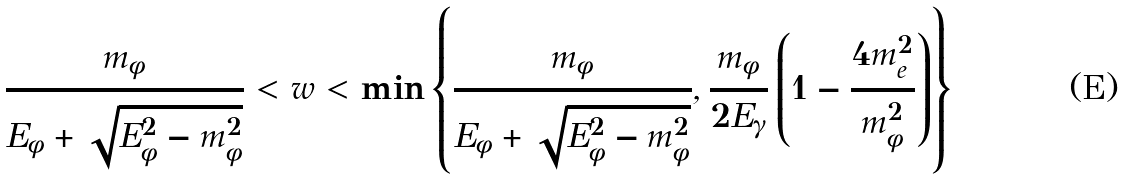<formula> <loc_0><loc_0><loc_500><loc_500>\frac { m _ { \phi } } { E _ { \phi } + \sqrt { E _ { \phi } ^ { 2 } - m _ { \phi } ^ { 2 } } } < w < \min \left \{ \frac { m _ { \phi } } { E _ { \phi } + \sqrt { E _ { \phi } ^ { 2 } - m _ { \phi } ^ { 2 } } } , \frac { m _ { \phi } } { 2 E _ { \gamma } } \left ( 1 - \frac { 4 m _ { e } ^ { 2 } } { m _ { \phi } ^ { 2 } } \right ) \right \}</formula> 